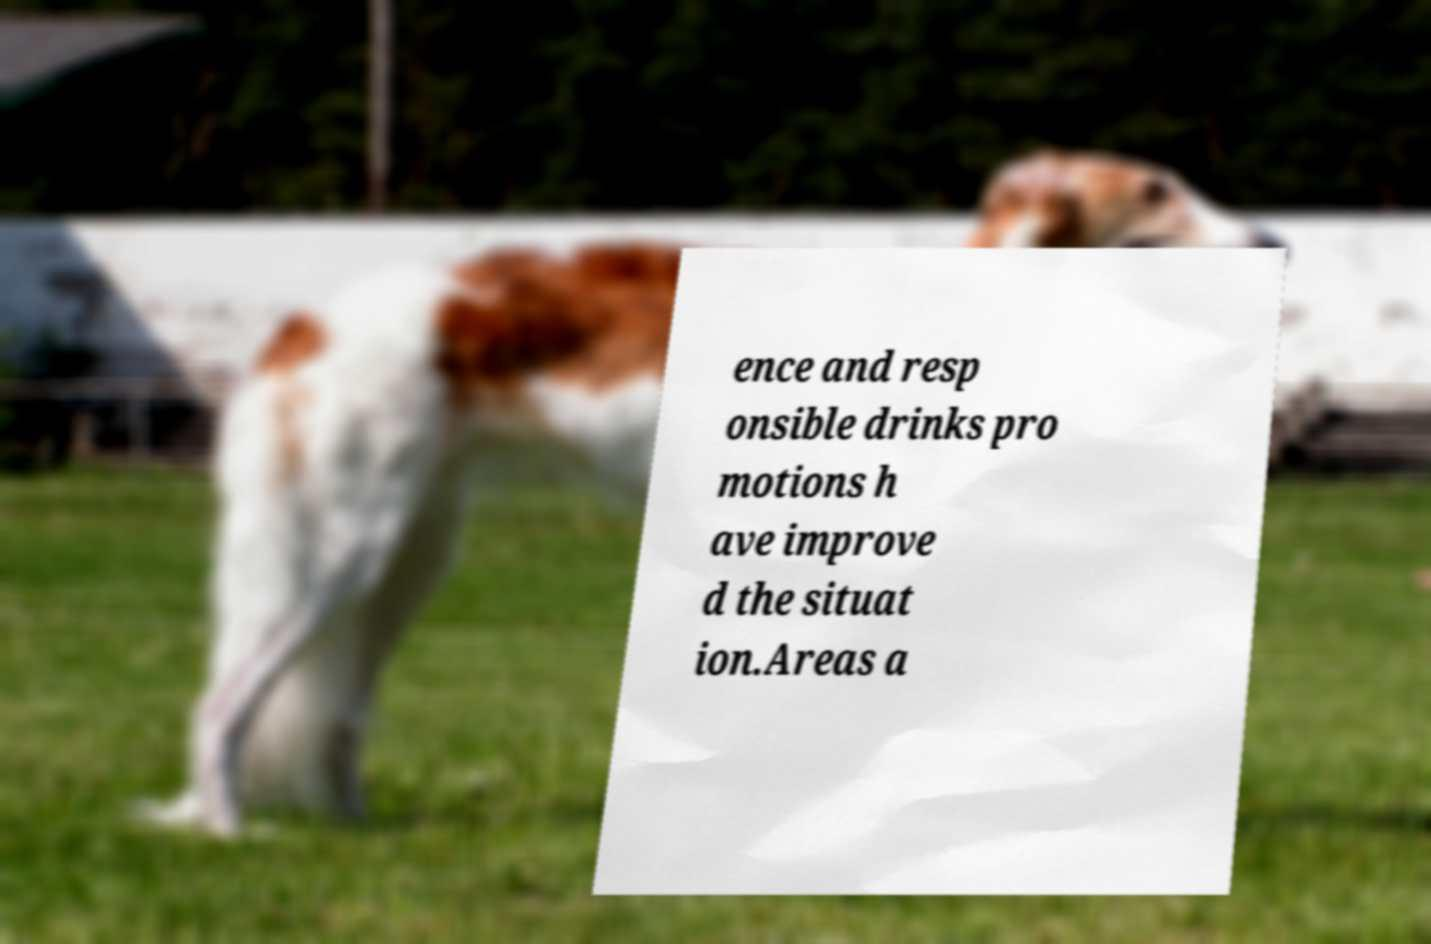There's text embedded in this image that I need extracted. Can you transcribe it verbatim? ence and resp onsible drinks pro motions h ave improve d the situat ion.Areas a 